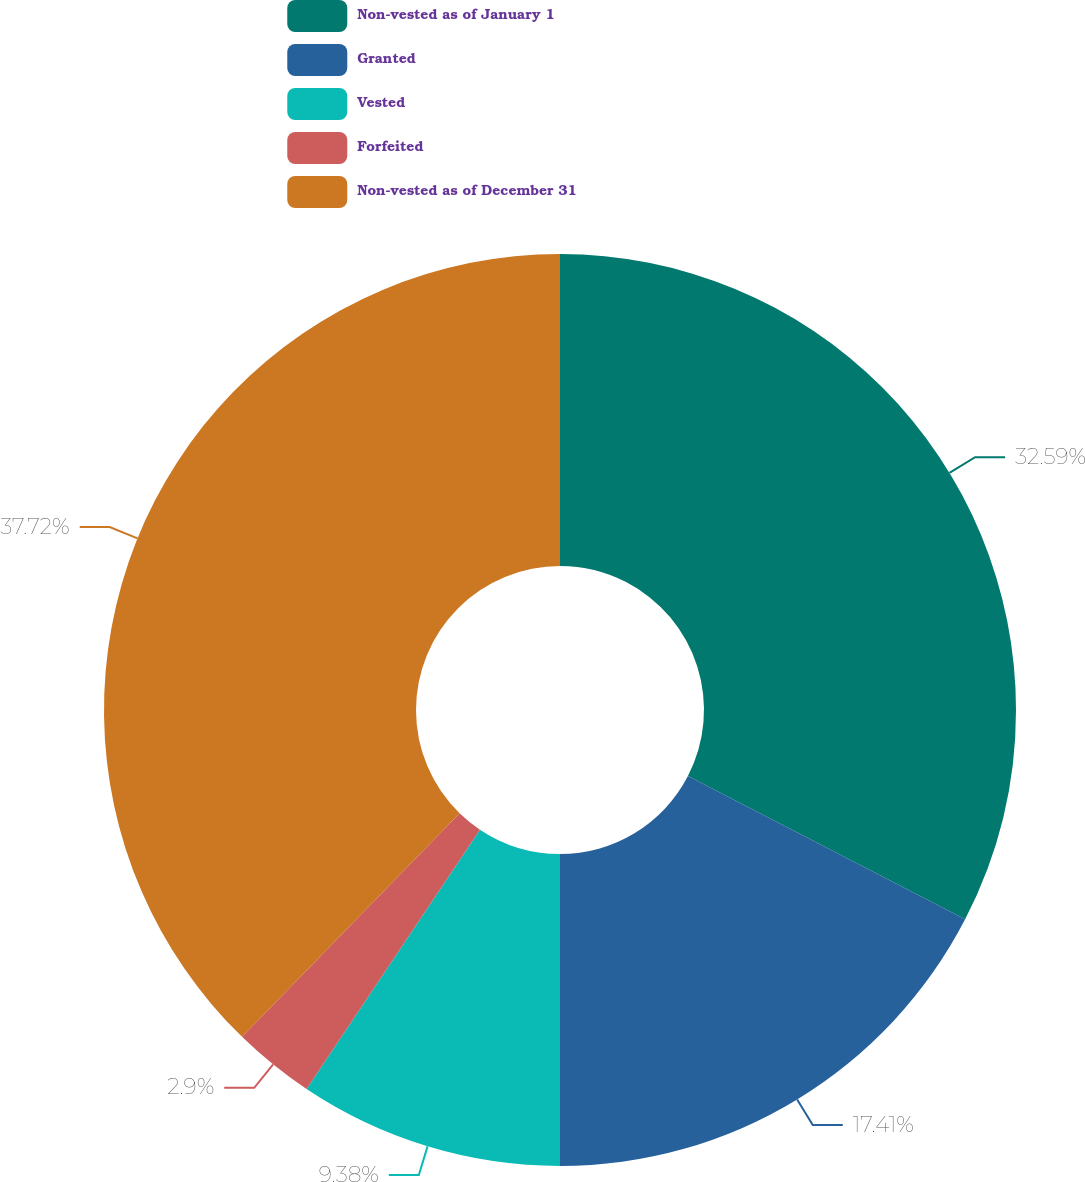<chart> <loc_0><loc_0><loc_500><loc_500><pie_chart><fcel>Non-vested as of January 1<fcel>Granted<fcel>Vested<fcel>Forfeited<fcel>Non-vested as of December 31<nl><fcel>32.59%<fcel>17.41%<fcel>9.38%<fcel>2.9%<fcel>37.72%<nl></chart> 